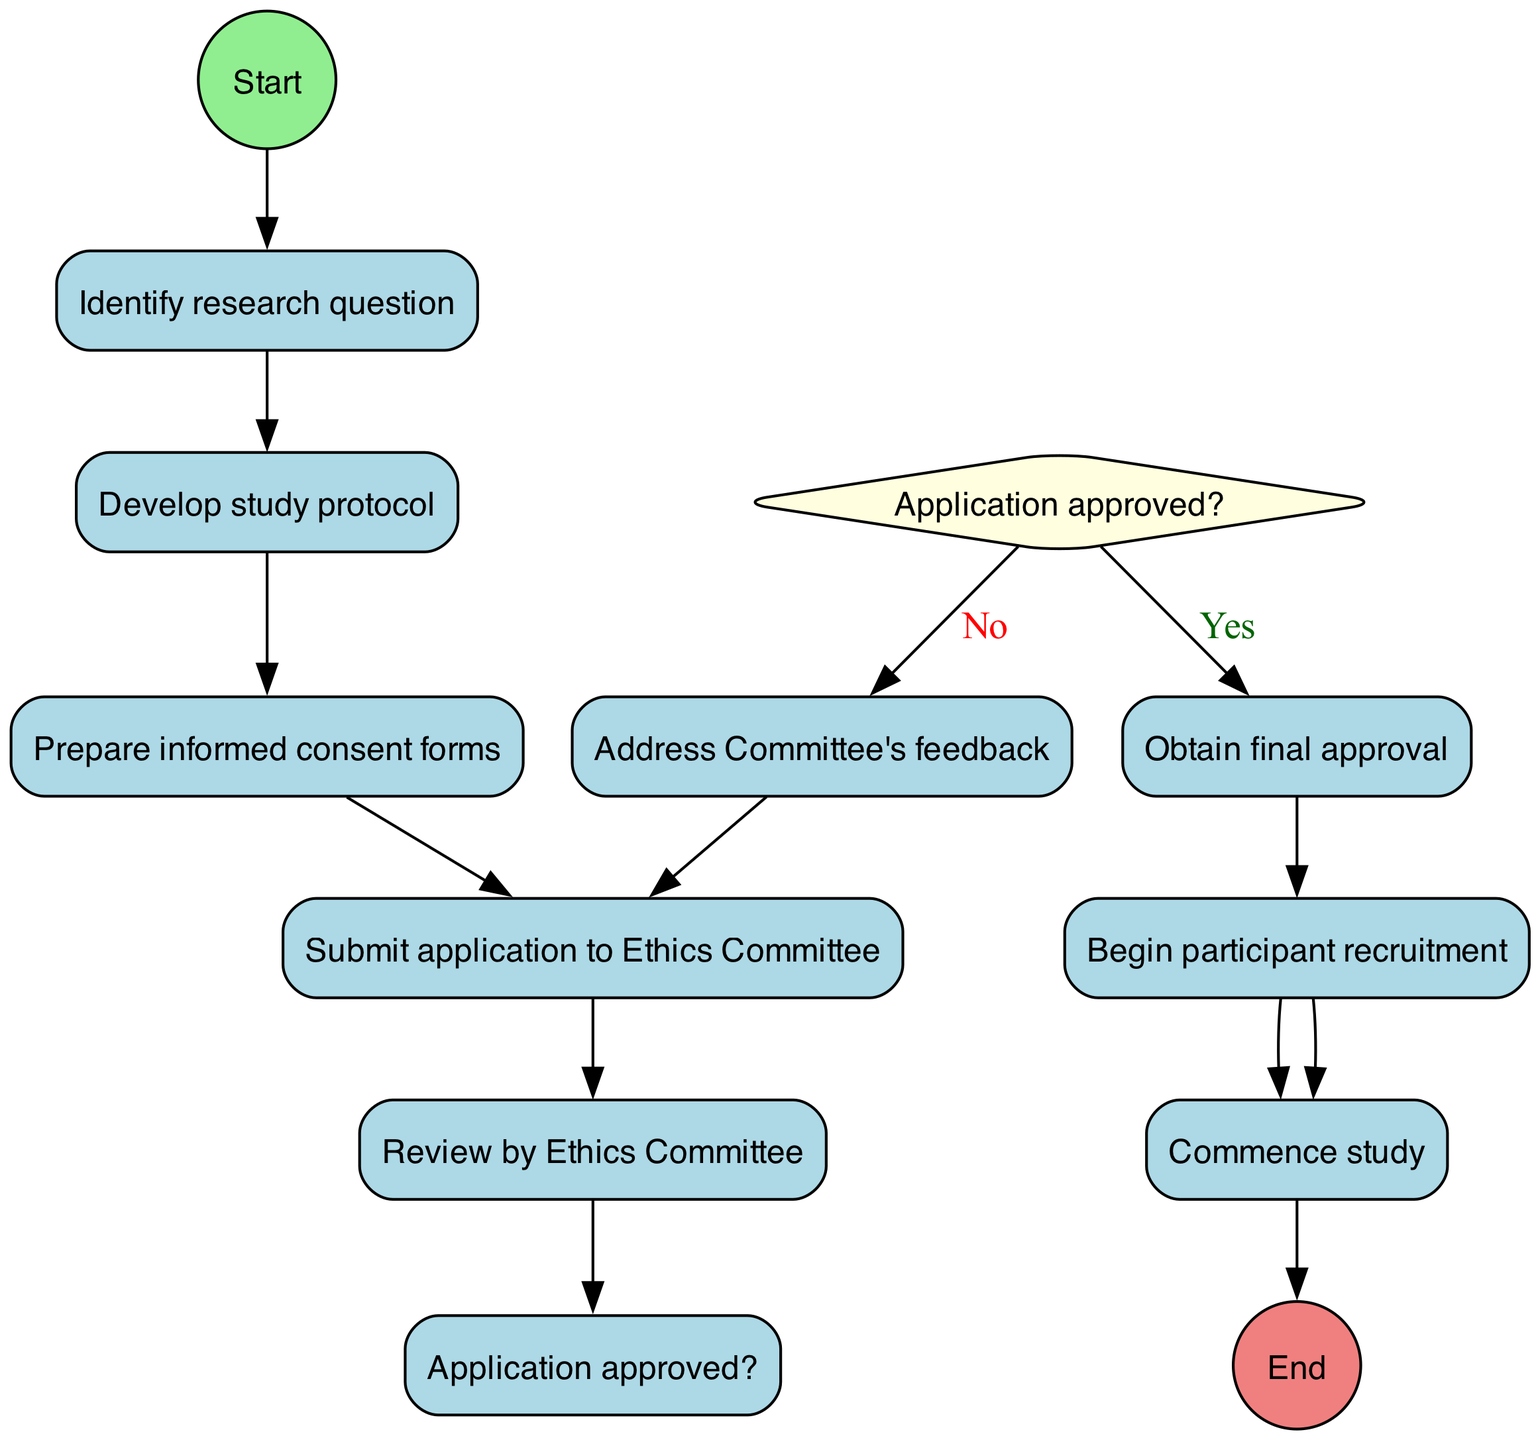What is the initial node of the diagram? The initial node of the diagram is indicated at the top, labeled "Identify research question." This is the starting point of the process outlined in the activity diagram.
Answer: Identify research question How many nodes are in the diagram? To find the total number of nodes, we count all unique activities, decision points, and start/end points. There are 7 activities, 1 decision, 1 initial node, and 1 final node, totaling 10 nodes.
Answer: 10 What is the last activity before obtaining final approval? The last activity directly preceding "Obtain final approval" is "Address Committee's feedback." We trace back from the decision point where the application is either approved or feedback is addressed.
Answer: Address Committee's feedback What happens after the "Review by Ethics Committee"? After "Review by Ethics Committee," there is a decision point asking "Application approved?" This decision will determine the flow to either obtaining final approval or addressing feedback.
Answer: Application approved? If the application is approved, what is the next step? If the application is approved, the next step following “Application approved?” is “Obtain final approval.” This is based on the yes branch of the decision node.
Answer: Obtain final approval What is the relationship between "Submit application to Ethics Committee" and "Begin participant recruitment"? "Submit application to Ethics Committee" is followed by "Review by Ethics Committee," and, contingent upon the approval, leads eventually to "Begin participant recruitment" after "Obtain final approval." These steps show the flow from application submission to recruitment.
Answer: Sequential relationship How many activities require feedback from the Committee? Only one activity requires addressing feedback from the Committee, which is indicated as "Address Committee's feedback." This step only occurs if the application is not approved.
Answer: One What is the final node of the diagram? The final node of the diagram, representing the conclusion of the process, is labeled "End." This node signifies that the study has commenced following successful final approval.
Answer: End What decision is taken during the "Review by Ethics Committee"? During this stage, the critical decision taken is whether the application is approved or not. This decision determines the subsequent action in the flow of the process.
Answer: Application approved? 